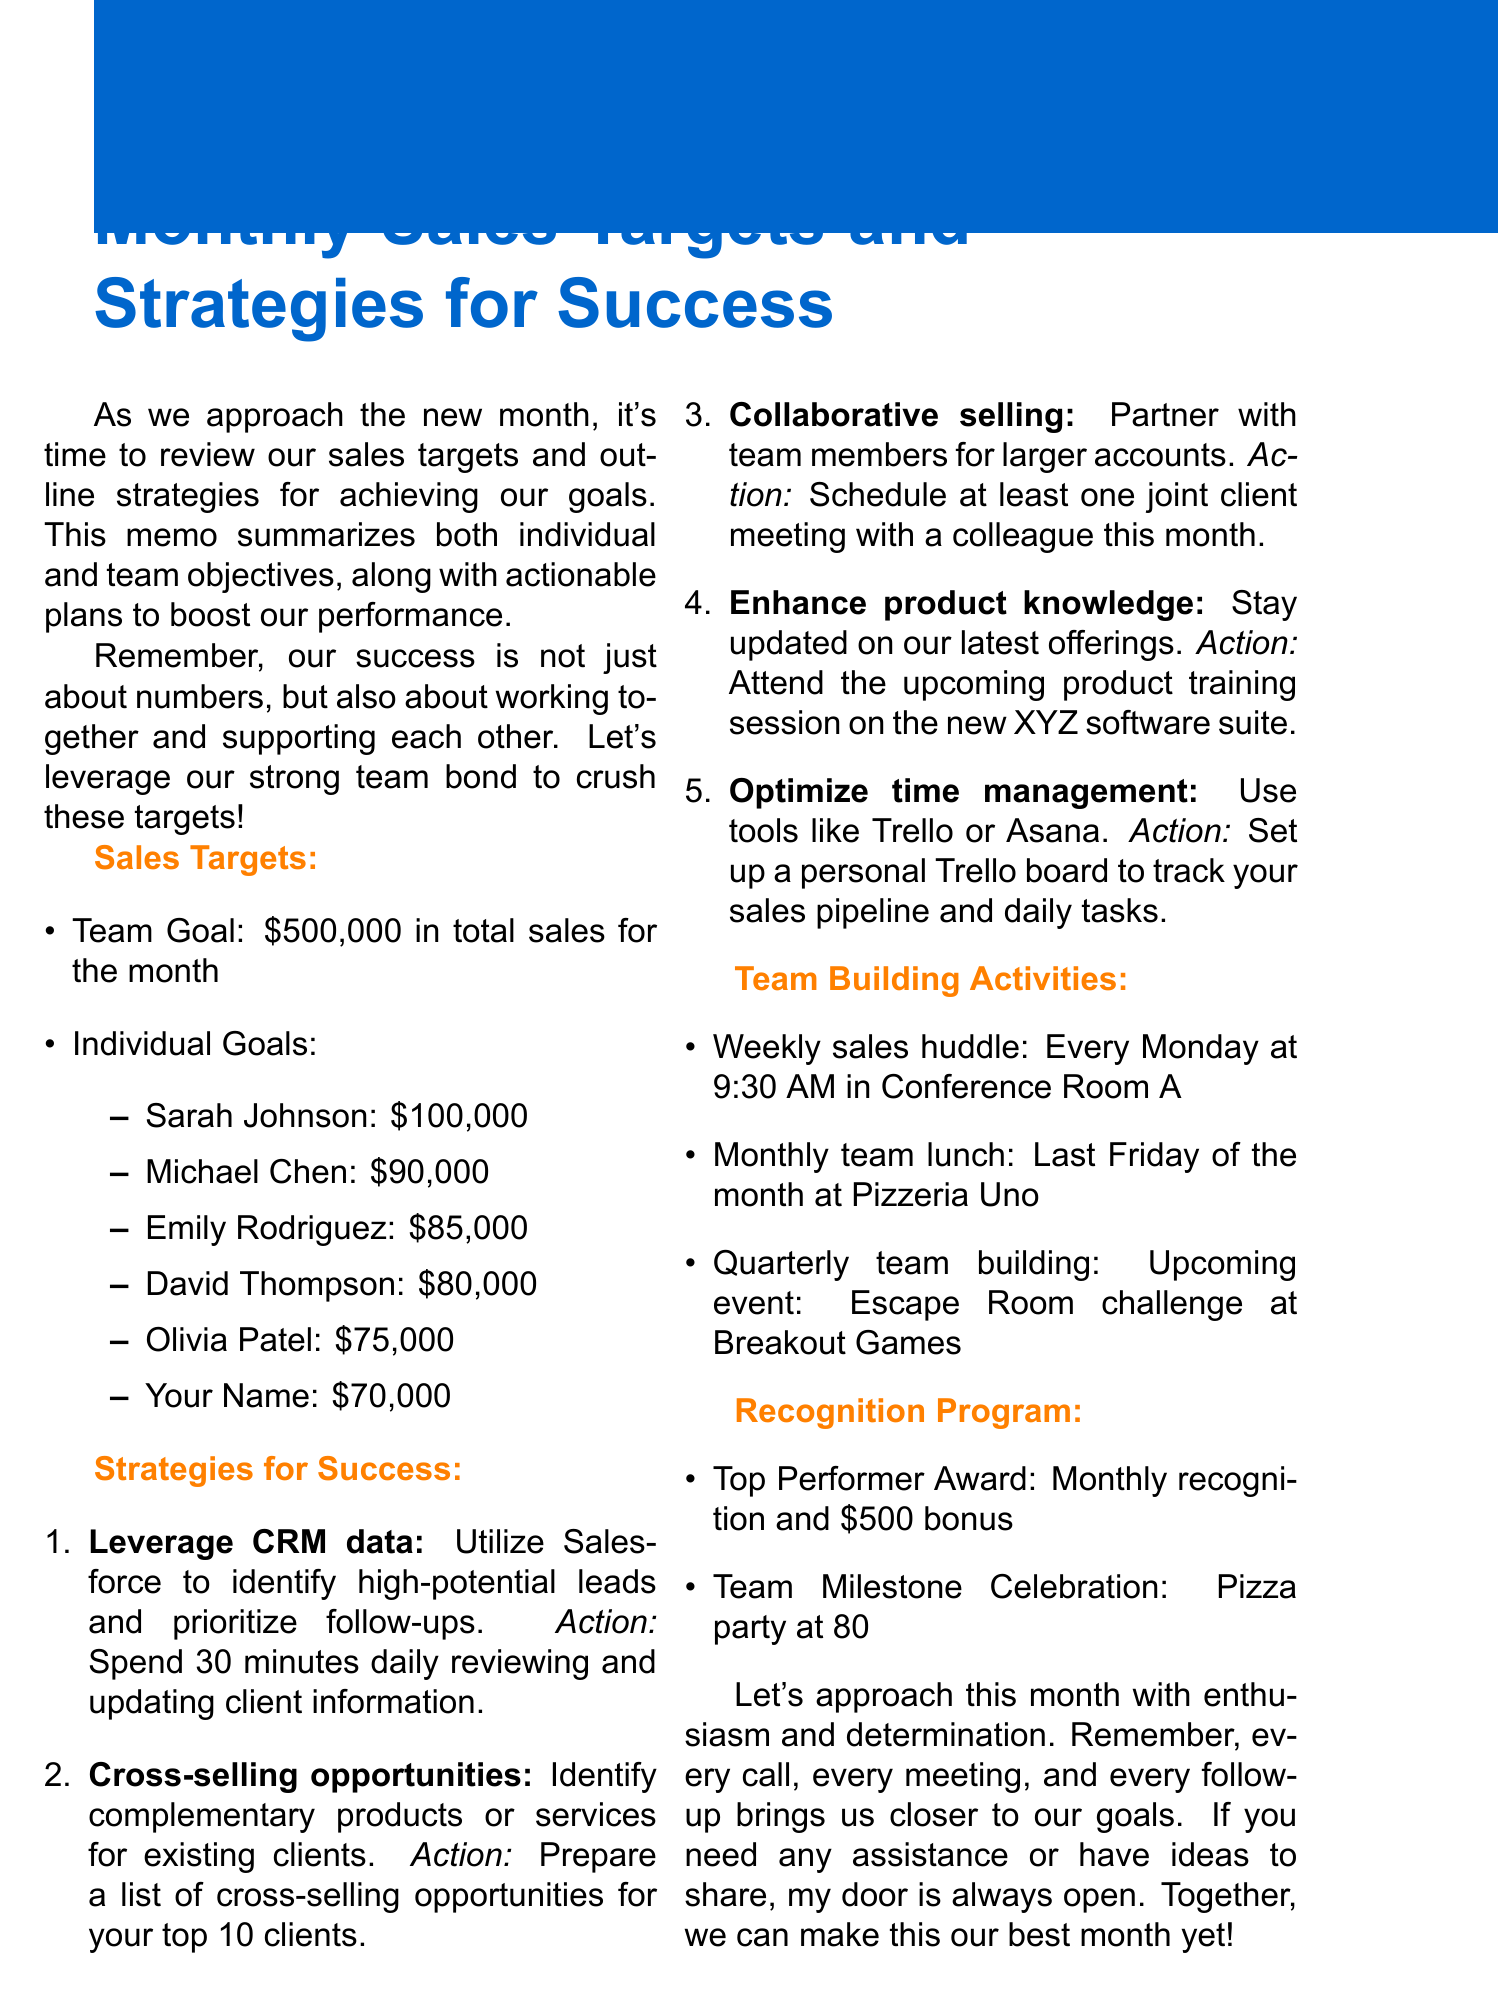What is the total team sales goal for the month? The document states that the total team sales goal is $500,000.
Answer: $500,000 Who has the highest individual sales target? Sarah Johnson is listed as having the highest individual sales target at $100,000.
Answer: Sarah Johnson What strategy suggests using Salesforce? The strategy titled "Leverage CRM data" suggests using Salesforce.
Answer: Leverage CRM data How many team-building activities are listed in the document? There are three team-building activities mentioned: weekly sales huddle, monthly team lunch, and quarterly team building.
Answer: 3 What is the incentive given for the top performer award? The top performer award includes monthly recognition and a $500 bonus.
Answer: $500 bonus Which day is the monthly team lunch scheduled? The document specifies that the monthly team lunch is scheduled for the last Friday of the month.
Answer: Last Friday What is the action item for enhancing product knowledge? The action item is to attend the upcoming product training session on the new XYZ software suite.
Answer: Attend product training session What is the time for the weekly sales huddle? The weekly sales huddle is scheduled for every Monday at 9:30 AM.
Answer: 9:30 AM 